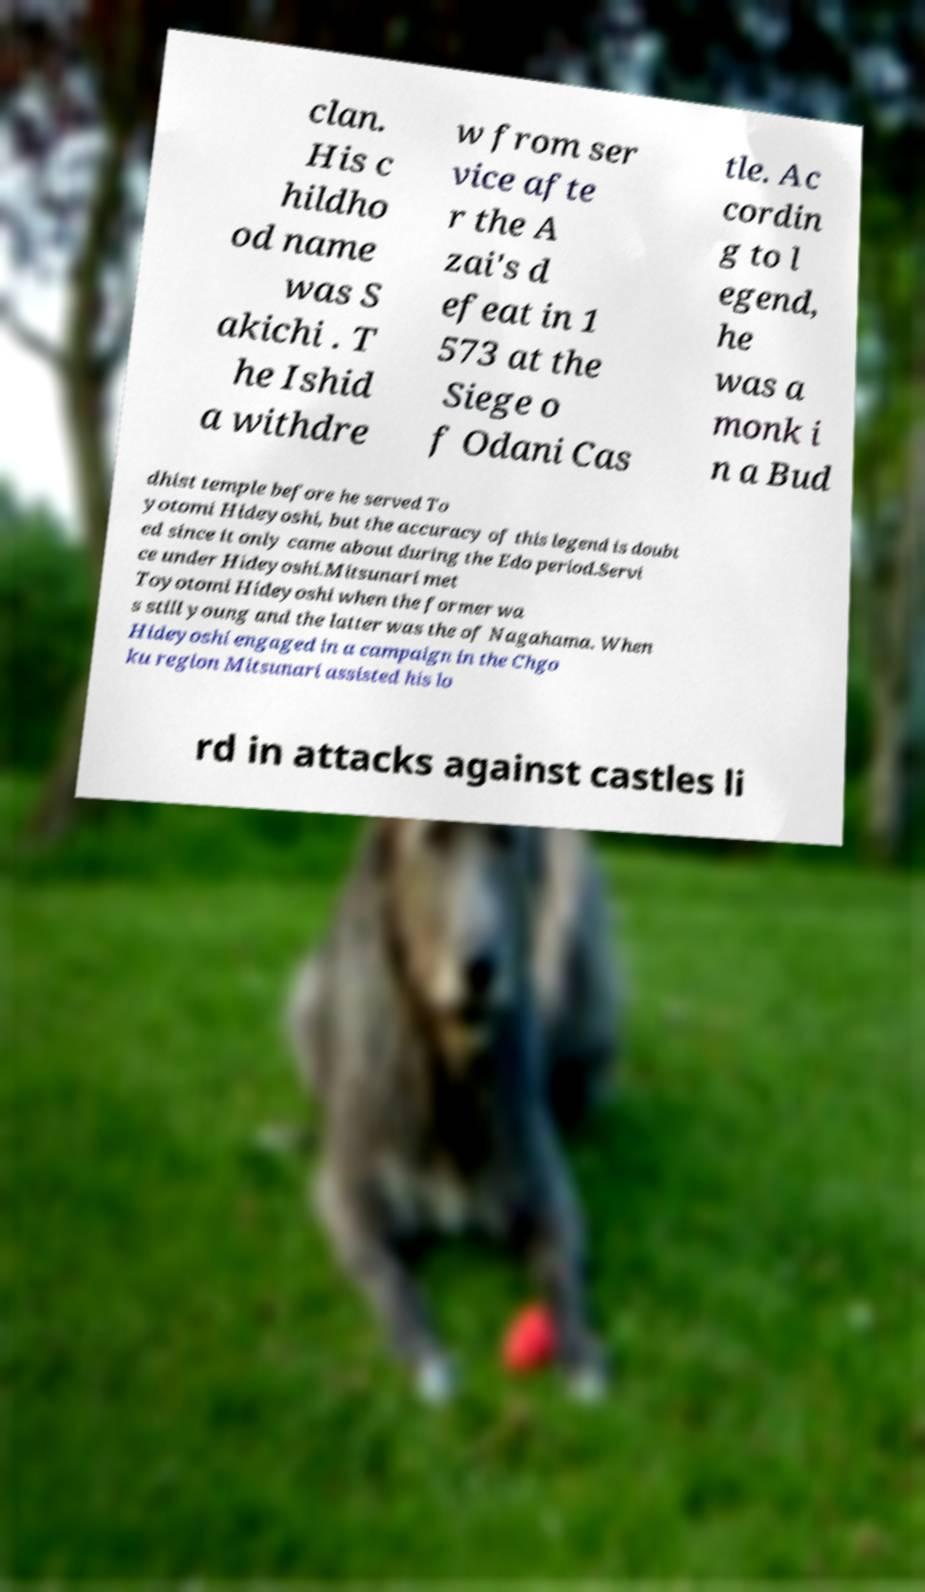Please identify and transcribe the text found in this image. clan. His c hildho od name was S akichi . T he Ishid a withdre w from ser vice afte r the A zai's d efeat in 1 573 at the Siege o f Odani Cas tle. Ac cordin g to l egend, he was a monk i n a Bud dhist temple before he served To yotomi Hideyoshi, but the accuracy of this legend is doubt ed since it only came about during the Edo period.Servi ce under Hideyoshi.Mitsunari met Toyotomi Hideyoshi when the former wa s still young and the latter was the of Nagahama. When Hideyoshi engaged in a campaign in the Chgo ku region Mitsunari assisted his lo rd in attacks against castles li 